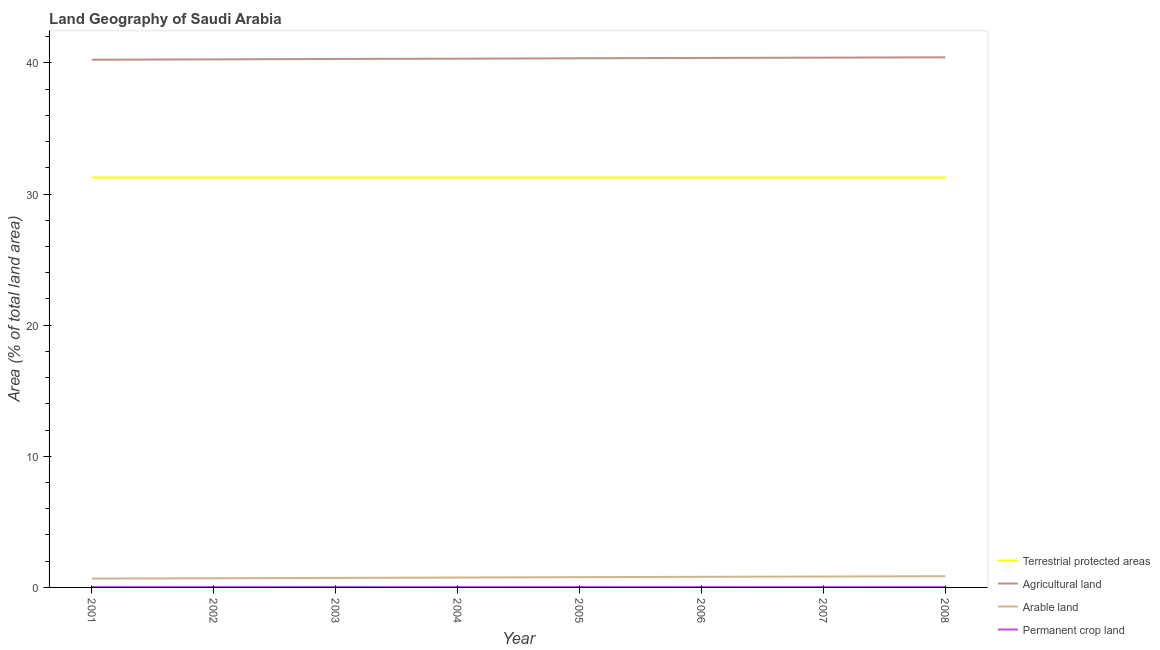How many different coloured lines are there?
Provide a short and direct response. 4. What is the percentage of area under permanent crop land in 2008?
Ensure brevity in your answer.  0.03. Across all years, what is the maximum percentage of area under permanent crop land?
Provide a succinct answer. 0.04. Across all years, what is the minimum percentage of area under permanent crop land?
Make the answer very short. 0.03. In which year was the percentage of area under permanent crop land maximum?
Ensure brevity in your answer.  2003. In which year was the percentage of area under permanent crop land minimum?
Your answer should be compact. 2004. What is the total percentage of area under permanent crop land in the graph?
Provide a short and direct response. 0.26. What is the difference between the percentage of area under permanent crop land in 2002 and that in 2003?
Your answer should be compact. -0. What is the difference between the percentage of area under arable land in 2002 and the percentage of area under agricultural land in 2004?
Your answer should be very brief. -39.63. What is the average percentage of area under permanent crop land per year?
Offer a terse response. 0.03. In the year 2003, what is the difference between the percentage of area under permanent crop land and percentage of area under arable land?
Provide a short and direct response. -0.69. In how many years, is the percentage of area under agricultural land greater than 2 %?
Make the answer very short. 8. What is the ratio of the percentage of area under arable land in 2001 to that in 2008?
Offer a terse response. 0.79. Is the percentage of area under agricultural land in 2005 less than that in 2008?
Ensure brevity in your answer.  Yes. Is the difference between the percentage of area under permanent crop land in 2003 and 2008 greater than the difference between the percentage of land under terrestrial protection in 2003 and 2008?
Your response must be concise. Yes. What is the difference between the highest and the lowest percentage of area under agricultural land?
Offer a terse response. 0.18. Is it the case that in every year, the sum of the percentage of area under permanent crop land and percentage of land under terrestrial protection is greater than the sum of percentage of area under agricultural land and percentage of area under arable land?
Provide a succinct answer. No. Does the percentage of area under arable land monotonically increase over the years?
Keep it short and to the point. Yes. Is the percentage of land under terrestrial protection strictly less than the percentage of area under arable land over the years?
Ensure brevity in your answer.  No. How many years are there in the graph?
Give a very brief answer. 8. What is the difference between two consecutive major ticks on the Y-axis?
Your answer should be very brief. 10. Does the graph contain any zero values?
Your response must be concise. No. How are the legend labels stacked?
Your response must be concise. Vertical. What is the title of the graph?
Make the answer very short. Land Geography of Saudi Arabia. What is the label or title of the Y-axis?
Your response must be concise. Area (% of total land area). What is the Area (% of total land area) in Terrestrial protected areas in 2001?
Keep it short and to the point. 31.26. What is the Area (% of total land area) of Agricultural land in 2001?
Keep it short and to the point. 40.25. What is the Area (% of total land area) of Arable land in 2001?
Your response must be concise. 0.67. What is the Area (% of total land area) of Permanent crop land in 2001?
Offer a terse response. 0.03. What is the Area (% of total land area) in Terrestrial protected areas in 2002?
Your response must be concise. 31.26. What is the Area (% of total land area) in Agricultural land in 2002?
Provide a succinct answer. 40.27. What is the Area (% of total land area) of Arable land in 2002?
Make the answer very short. 0.7. What is the Area (% of total land area) in Permanent crop land in 2002?
Offer a terse response. 0.03. What is the Area (% of total land area) in Terrestrial protected areas in 2003?
Your answer should be compact. 31.26. What is the Area (% of total land area) in Agricultural land in 2003?
Offer a terse response. 40.3. What is the Area (% of total land area) in Arable land in 2003?
Provide a short and direct response. 0.73. What is the Area (% of total land area) in Permanent crop land in 2003?
Make the answer very short. 0.04. What is the Area (% of total land area) in Terrestrial protected areas in 2004?
Give a very brief answer. 31.26. What is the Area (% of total land area) of Agricultural land in 2004?
Provide a short and direct response. 40.32. What is the Area (% of total land area) of Arable land in 2004?
Keep it short and to the point. 0.75. What is the Area (% of total land area) of Permanent crop land in 2004?
Offer a terse response. 0.03. What is the Area (% of total land area) of Terrestrial protected areas in 2005?
Offer a very short reply. 31.26. What is the Area (% of total land area) of Agricultural land in 2005?
Keep it short and to the point. 40.35. What is the Area (% of total land area) of Arable land in 2005?
Your answer should be very brief. 0.78. What is the Area (% of total land area) in Permanent crop land in 2005?
Your response must be concise. 0.03. What is the Area (% of total land area) of Terrestrial protected areas in 2006?
Provide a succinct answer. 31.26. What is the Area (% of total land area) in Agricultural land in 2006?
Your response must be concise. 40.38. What is the Area (% of total land area) in Arable land in 2006?
Provide a short and direct response. 0.81. What is the Area (% of total land area) of Permanent crop land in 2006?
Ensure brevity in your answer.  0.03. What is the Area (% of total land area) of Terrestrial protected areas in 2007?
Provide a short and direct response. 31.26. What is the Area (% of total land area) in Agricultural land in 2007?
Your response must be concise. 40.4. What is the Area (% of total land area) in Arable land in 2007?
Ensure brevity in your answer.  0.83. What is the Area (% of total land area) in Permanent crop land in 2007?
Give a very brief answer. 0.03. What is the Area (% of total land area) in Terrestrial protected areas in 2008?
Your answer should be compact. 31.26. What is the Area (% of total land area) in Agricultural land in 2008?
Ensure brevity in your answer.  40.43. What is the Area (% of total land area) of Arable land in 2008?
Make the answer very short. 0.86. What is the Area (% of total land area) in Permanent crop land in 2008?
Offer a very short reply. 0.03. Across all years, what is the maximum Area (% of total land area) in Terrestrial protected areas?
Make the answer very short. 31.26. Across all years, what is the maximum Area (% of total land area) in Agricultural land?
Keep it short and to the point. 40.43. Across all years, what is the maximum Area (% of total land area) in Arable land?
Provide a succinct answer. 0.86. Across all years, what is the maximum Area (% of total land area) of Permanent crop land?
Offer a terse response. 0.04. Across all years, what is the minimum Area (% of total land area) in Terrestrial protected areas?
Give a very brief answer. 31.26. Across all years, what is the minimum Area (% of total land area) of Agricultural land?
Make the answer very short. 40.25. Across all years, what is the minimum Area (% of total land area) in Arable land?
Your answer should be very brief. 0.67. Across all years, what is the minimum Area (% of total land area) of Permanent crop land?
Your answer should be compact. 0.03. What is the total Area (% of total land area) in Terrestrial protected areas in the graph?
Your answer should be very brief. 250.1. What is the total Area (% of total land area) in Agricultural land in the graph?
Offer a very short reply. 322.71. What is the total Area (% of total land area) in Arable land in the graph?
Offer a terse response. 6.13. What is the total Area (% of total land area) in Permanent crop land in the graph?
Your answer should be very brief. 0.26. What is the difference between the Area (% of total land area) of Terrestrial protected areas in 2001 and that in 2002?
Give a very brief answer. 0. What is the difference between the Area (% of total land area) in Agricultural land in 2001 and that in 2002?
Ensure brevity in your answer.  -0.02. What is the difference between the Area (% of total land area) of Arable land in 2001 and that in 2002?
Your answer should be very brief. -0.02. What is the difference between the Area (% of total land area) in Permanent crop land in 2001 and that in 2002?
Ensure brevity in your answer.  -0. What is the difference between the Area (% of total land area) of Terrestrial protected areas in 2001 and that in 2003?
Give a very brief answer. 0. What is the difference between the Area (% of total land area) in Agricultural land in 2001 and that in 2003?
Provide a succinct answer. -0.06. What is the difference between the Area (% of total land area) in Arable land in 2001 and that in 2003?
Ensure brevity in your answer.  -0.05. What is the difference between the Area (% of total land area) in Permanent crop land in 2001 and that in 2003?
Provide a succinct answer. -0.01. What is the difference between the Area (% of total land area) in Agricultural land in 2001 and that in 2004?
Keep it short and to the point. -0.08. What is the difference between the Area (% of total land area) in Arable land in 2001 and that in 2004?
Provide a succinct answer. -0.08. What is the difference between the Area (% of total land area) of Permanent crop land in 2001 and that in 2004?
Provide a succinct answer. 0. What is the difference between the Area (% of total land area) in Agricultural land in 2001 and that in 2005?
Your response must be concise. -0.11. What is the difference between the Area (% of total land area) in Arable land in 2001 and that in 2005?
Give a very brief answer. -0.11. What is the difference between the Area (% of total land area) of Permanent crop land in 2001 and that in 2005?
Give a very brief answer. -0. What is the difference between the Area (% of total land area) of Agricultural land in 2001 and that in 2006?
Your answer should be very brief. -0.13. What is the difference between the Area (% of total land area) of Arable land in 2001 and that in 2006?
Keep it short and to the point. -0.13. What is the difference between the Area (% of total land area) of Permanent crop land in 2001 and that in 2006?
Offer a very short reply. 0. What is the difference between the Area (% of total land area) of Terrestrial protected areas in 2001 and that in 2007?
Your answer should be very brief. 0. What is the difference between the Area (% of total land area) in Agricultural land in 2001 and that in 2007?
Give a very brief answer. -0.16. What is the difference between the Area (% of total land area) of Arable land in 2001 and that in 2007?
Your answer should be compact. -0.16. What is the difference between the Area (% of total land area) of Permanent crop land in 2001 and that in 2007?
Offer a terse response. 0. What is the difference between the Area (% of total land area) of Agricultural land in 2001 and that in 2008?
Make the answer very short. -0.18. What is the difference between the Area (% of total land area) of Arable land in 2001 and that in 2008?
Provide a short and direct response. -0.18. What is the difference between the Area (% of total land area) of Permanent crop land in 2001 and that in 2008?
Keep it short and to the point. -0. What is the difference between the Area (% of total land area) of Agricultural land in 2002 and that in 2003?
Keep it short and to the point. -0.03. What is the difference between the Area (% of total land area) in Arable land in 2002 and that in 2003?
Provide a succinct answer. -0.03. What is the difference between the Area (% of total land area) in Permanent crop land in 2002 and that in 2003?
Offer a very short reply. -0. What is the difference between the Area (% of total land area) in Terrestrial protected areas in 2002 and that in 2004?
Give a very brief answer. 0. What is the difference between the Area (% of total land area) in Agricultural land in 2002 and that in 2004?
Your response must be concise. -0.05. What is the difference between the Area (% of total land area) in Arable land in 2002 and that in 2004?
Your response must be concise. -0.06. What is the difference between the Area (% of total land area) of Permanent crop land in 2002 and that in 2004?
Ensure brevity in your answer.  0. What is the difference between the Area (% of total land area) in Agricultural land in 2002 and that in 2005?
Offer a terse response. -0.08. What is the difference between the Area (% of total land area) of Arable land in 2002 and that in 2005?
Make the answer very short. -0.08. What is the difference between the Area (% of total land area) of Permanent crop land in 2002 and that in 2005?
Provide a short and direct response. 0. What is the difference between the Area (% of total land area) in Terrestrial protected areas in 2002 and that in 2006?
Ensure brevity in your answer.  0. What is the difference between the Area (% of total land area) of Agricultural land in 2002 and that in 2006?
Provide a short and direct response. -0.11. What is the difference between the Area (% of total land area) of Arable land in 2002 and that in 2006?
Provide a succinct answer. -0.11. What is the difference between the Area (% of total land area) of Permanent crop land in 2002 and that in 2006?
Provide a short and direct response. 0. What is the difference between the Area (% of total land area) of Agricultural land in 2002 and that in 2007?
Ensure brevity in your answer.  -0.13. What is the difference between the Area (% of total land area) in Arable land in 2002 and that in 2007?
Your answer should be very brief. -0.13. What is the difference between the Area (% of total land area) in Permanent crop land in 2002 and that in 2007?
Your response must be concise. 0. What is the difference between the Area (% of total land area) of Agricultural land in 2002 and that in 2008?
Offer a terse response. -0.16. What is the difference between the Area (% of total land area) of Arable land in 2002 and that in 2008?
Provide a succinct answer. -0.16. What is the difference between the Area (% of total land area) in Agricultural land in 2003 and that in 2004?
Give a very brief answer. -0.02. What is the difference between the Area (% of total land area) of Arable land in 2003 and that in 2004?
Your response must be concise. -0.03. What is the difference between the Area (% of total land area) of Permanent crop land in 2003 and that in 2004?
Give a very brief answer. 0.01. What is the difference between the Area (% of total land area) in Agricultural land in 2003 and that in 2005?
Provide a succinct answer. -0.05. What is the difference between the Area (% of total land area) of Arable land in 2003 and that in 2005?
Your answer should be very brief. -0.06. What is the difference between the Area (% of total land area) in Permanent crop land in 2003 and that in 2005?
Make the answer very short. 0. What is the difference between the Area (% of total land area) of Terrestrial protected areas in 2003 and that in 2006?
Keep it short and to the point. 0. What is the difference between the Area (% of total land area) of Agricultural land in 2003 and that in 2006?
Provide a succinct answer. -0.08. What is the difference between the Area (% of total land area) of Arable land in 2003 and that in 2006?
Keep it short and to the point. -0.08. What is the difference between the Area (% of total land area) of Permanent crop land in 2003 and that in 2006?
Provide a short and direct response. 0.01. What is the difference between the Area (% of total land area) in Terrestrial protected areas in 2003 and that in 2007?
Your answer should be very brief. 0. What is the difference between the Area (% of total land area) in Agricultural land in 2003 and that in 2007?
Make the answer very short. -0.1. What is the difference between the Area (% of total land area) in Arable land in 2003 and that in 2007?
Give a very brief answer. -0.11. What is the difference between the Area (% of total land area) of Permanent crop land in 2003 and that in 2007?
Provide a succinct answer. 0.01. What is the difference between the Area (% of total land area) in Terrestrial protected areas in 2003 and that in 2008?
Make the answer very short. 0. What is the difference between the Area (% of total land area) of Agricultural land in 2003 and that in 2008?
Offer a very short reply. -0.13. What is the difference between the Area (% of total land area) of Arable land in 2003 and that in 2008?
Ensure brevity in your answer.  -0.13. What is the difference between the Area (% of total land area) of Permanent crop land in 2003 and that in 2008?
Your answer should be compact. 0.01. What is the difference between the Area (% of total land area) in Agricultural land in 2004 and that in 2005?
Your response must be concise. -0.03. What is the difference between the Area (% of total land area) of Arable land in 2004 and that in 2005?
Offer a terse response. -0.03. What is the difference between the Area (% of total land area) in Permanent crop land in 2004 and that in 2005?
Give a very brief answer. -0. What is the difference between the Area (% of total land area) in Agricultural land in 2004 and that in 2006?
Ensure brevity in your answer.  -0.06. What is the difference between the Area (% of total land area) of Arable land in 2004 and that in 2006?
Provide a short and direct response. -0.06. What is the difference between the Area (% of total land area) of Terrestrial protected areas in 2004 and that in 2007?
Your answer should be very brief. 0. What is the difference between the Area (% of total land area) of Agricultural land in 2004 and that in 2007?
Offer a terse response. -0.08. What is the difference between the Area (% of total land area) of Arable land in 2004 and that in 2007?
Give a very brief answer. -0.08. What is the difference between the Area (% of total land area) in Permanent crop land in 2004 and that in 2007?
Offer a very short reply. -0. What is the difference between the Area (% of total land area) of Agricultural land in 2004 and that in 2008?
Provide a short and direct response. -0.1. What is the difference between the Area (% of total land area) in Arable land in 2004 and that in 2008?
Your response must be concise. -0.1. What is the difference between the Area (% of total land area) in Permanent crop land in 2004 and that in 2008?
Your answer should be compact. -0. What is the difference between the Area (% of total land area) in Agricultural land in 2005 and that in 2006?
Give a very brief answer. -0.03. What is the difference between the Area (% of total land area) in Arable land in 2005 and that in 2006?
Offer a very short reply. -0.03. What is the difference between the Area (% of total land area) of Permanent crop land in 2005 and that in 2006?
Your response must be concise. 0. What is the difference between the Area (% of total land area) in Terrestrial protected areas in 2005 and that in 2007?
Your answer should be very brief. 0. What is the difference between the Area (% of total land area) in Agricultural land in 2005 and that in 2007?
Provide a succinct answer. -0.05. What is the difference between the Area (% of total land area) of Arable land in 2005 and that in 2007?
Offer a terse response. -0.05. What is the difference between the Area (% of total land area) in Permanent crop land in 2005 and that in 2007?
Offer a very short reply. 0. What is the difference between the Area (% of total land area) of Terrestrial protected areas in 2005 and that in 2008?
Give a very brief answer. 0. What is the difference between the Area (% of total land area) of Agricultural land in 2005 and that in 2008?
Your response must be concise. -0.07. What is the difference between the Area (% of total land area) in Arable land in 2005 and that in 2008?
Keep it short and to the point. -0.07. What is the difference between the Area (% of total land area) in Terrestrial protected areas in 2006 and that in 2007?
Ensure brevity in your answer.  0. What is the difference between the Area (% of total land area) of Agricultural land in 2006 and that in 2007?
Give a very brief answer. -0.02. What is the difference between the Area (% of total land area) in Arable land in 2006 and that in 2007?
Provide a short and direct response. -0.02. What is the difference between the Area (% of total land area) of Permanent crop land in 2006 and that in 2007?
Make the answer very short. -0. What is the difference between the Area (% of total land area) of Agricultural land in 2006 and that in 2008?
Give a very brief answer. -0.05. What is the difference between the Area (% of total land area) in Arable land in 2006 and that in 2008?
Your answer should be compact. -0.05. What is the difference between the Area (% of total land area) in Permanent crop land in 2006 and that in 2008?
Your answer should be compact. -0. What is the difference between the Area (% of total land area) in Agricultural land in 2007 and that in 2008?
Ensure brevity in your answer.  -0.02. What is the difference between the Area (% of total land area) in Arable land in 2007 and that in 2008?
Offer a very short reply. -0.02. What is the difference between the Area (% of total land area) in Permanent crop land in 2007 and that in 2008?
Your answer should be very brief. -0. What is the difference between the Area (% of total land area) of Terrestrial protected areas in 2001 and the Area (% of total land area) of Agricultural land in 2002?
Provide a short and direct response. -9.01. What is the difference between the Area (% of total land area) in Terrestrial protected areas in 2001 and the Area (% of total land area) in Arable land in 2002?
Provide a succinct answer. 30.56. What is the difference between the Area (% of total land area) of Terrestrial protected areas in 2001 and the Area (% of total land area) of Permanent crop land in 2002?
Give a very brief answer. 31.23. What is the difference between the Area (% of total land area) in Agricultural land in 2001 and the Area (% of total land area) in Arable land in 2002?
Ensure brevity in your answer.  39.55. What is the difference between the Area (% of total land area) of Agricultural land in 2001 and the Area (% of total land area) of Permanent crop land in 2002?
Provide a succinct answer. 40.21. What is the difference between the Area (% of total land area) of Arable land in 2001 and the Area (% of total land area) of Permanent crop land in 2002?
Make the answer very short. 0.64. What is the difference between the Area (% of total land area) of Terrestrial protected areas in 2001 and the Area (% of total land area) of Agricultural land in 2003?
Offer a terse response. -9.04. What is the difference between the Area (% of total land area) in Terrestrial protected areas in 2001 and the Area (% of total land area) in Arable land in 2003?
Offer a terse response. 30.54. What is the difference between the Area (% of total land area) in Terrestrial protected areas in 2001 and the Area (% of total land area) in Permanent crop land in 2003?
Your response must be concise. 31.22. What is the difference between the Area (% of total land area) in Agricultural land in 2001 and the Area (% of total land area) in Arable land in 2003?
Offer a terse response. 39.52. What is the difference between the Area (% of total land area) in Agricultural land in 2001 and the Area (% of total land area) in Permanent crop land in 2003?
Offer a terse response. 40.21. What is the difference between the Area (% of total land area) of Arable land in 2001 and the Area (% of total land area) of Permanent crop land in 2003?
Ensure brevity in your answer.  0.64. What is the difference between the Area (% of total land area) in Terrestrial protected areas in 2001 and the Area (% of total land area) in Agricultural land in 2004?
Ensure brevity in your answer.  -9.06. What is the difference between the Area (% of total land area) of Terrestrial protected areas in 2001 and the Area (% of total land area) of Arable land in 2004?
Offer a terse response. 30.51. What is the difference between the Area (% of total land area) in Terrestrial protected areas in 2001 and the Area (% of total land area) in Permanent crop land in 2004?
Your answer should be very brief. 31.23. What is the difference between the Area (% of total land area) in Agricultural land in 2001 and the Area (% of total land area) in Arable land in 2004?
Offer a very short reply. 39.49. What is the difference between the Area (% of total land area) of Agricultural land in 2001 and the Area (% of total land area) of Permanent crop land in 2004?
Provide a short and direct response. 40.22. What is the difference between the Area (% of total land area) of Arable land in 2001 and the Area (% of total land area) of Permanent crop land in 2004?
Give a very brief answer. 0.64. What is the difference between the Area (% of total land area) of Terrestrial protected areas in 2001 and the Area (% of total land area) of Agricultural land in 2005?
Offer a very short reply. -9.09. What is the difference between the Area (% of total land area) of Terrestrial protected areas in 2001 and the Area (% of total land area) of Arable land in 2005?
Your response must be concise. 30.48. What is the difference between the Area (% of total land area) of Terrestrial protected areas in 2001 and the Area (% of total land area) of Permanent crop land in 2005?
Your response must be concise. 31.23. What is the difference between the Area (% of total land area) in Agricultural land in 2001 and the Area (% of total land area) in Arable land in 2005?
Ensure brevity in your answer.  39.46. What is the difference between the Area (% of total land area) of Agricultural land in 2001 and the Area (% of total land area) of Permanent crop land in 2005?
Your response must be concise. 40.21. What is the difference between the Area (% of total land area) of Arable land in 2001 and the Area (% of total land area) of Permanent crop land in 2005?
Ensure brevity in your answer.  0.64. What is the difference between the Area (% of total land area) in Terrestrial protected areas in 2001 and the Area (% of total land area) in Agricultural land in 2006?
Give a very brief answer. -9.12. What is the difference between the Area (% of total land area) in Terrestrial protected areas in 2001 and the Area (% of total land area) in Arable land in 2006?
Your response must be concise. 30.45. What is the difference between the Area (% of total land area) in Terrestrial protected areas in 2001 and the Area (% of total land area) in Permanent crop land in 2006?
Make the answer very short. 31.23. What is the difference between the Area (% of total land area) in Agricultural land in 2001 and the Area (% of total land area) in Arable land in 2006?
Offer a very short reply. 39.44. What is the difference between the Area (% of total land area) in Agricultural land in 2001 and the Area (% of total land area) in Permanent crop land in 2006?
Offer a very short reply. 40.22. What is the difference between the Area (% of total land area) of Arable land in 2001 and the Area (% of total land area) of Permanent crop land in 2006?
Make the answer very short. 0.64. What is the difference between the Area (% of total land area) in Terrestrial protected areas in 2001 and the Area (% of total land area) in Agricultural land in 2007?
Your response must be concise. -9.14. What is the difference between the Area (% of total land area) in Terrestrial protected areas in 2001 and the Area (% of total land area) in Arable land in 2007?
Your answer should be very brief. 30.43. What is the difference between the Area (% of total land area) of Terrestrial protected areas in 2001 and the Area (% of total land area) of Permanent crop land in 2007?
Provide a short and direct response. 31.23. What is the difference between the Area (% of total land area) in Agricultural land in 2001 and the Area (% of total land area) in Arable land in 2007?
Your answer should be very brief. 39.41. What is the difference between the Area (% of total land area) of Agricultural land in 2001 and the Area (% of total land area) of Permanent crop land in 2007?
Your answer should be very brief. 40.22. What is the difference between the Area (% of total land area) in Arable land in 2001 and the Area (% of total land area) in Permanent crop land in 2007?
Offer a very short reply. 0.64. What is the difference between the Area (% of total land area) of Terrestrial protected areas in 2001 and the Area (% of total land area) of Agricultural land in 2008?
Offer a very short reply. -9.17. What is the difference between the Area (% of total land area) in Terrestrial protected areas in 2001 and the Area (% of total land area) in Arable land in 2008?
Your response must be concise. 30.41. What is the difference between the Area (% of total land area) in Terrestrial protected areas in 2001 and the Area (% of total land area) in Permanent crop land in 2008?
Provide a short and direct response. 31.23. What is the difference between the Area (% of total land area) in Agricultural land in 2001 and the Area (% of total land area) in Arable land in 2008?
Make the answer very short. 39.39. What is the difference between the Area (% of total land area) in Agricultural land in 2001 and the Area (% of total land area) in Permanent crop land in 2008?
Ensure brevity in your answer.  40.21. What is the difference between the Area (% of total land area) in Arable land in 2001 and the Area (% of total land area) in Permanent crop land in 2008?
Provide a short and direct response. 0.64. What is the difference between the Area (% of total land area) of Terrestrial protected areas in 2002 and the Area (% of total land area) of Agricultural land in 2003?
Give a very brief answer. -9.04. What is the difference between the Area (% of total land area) in Terrestrial protected areas in 2002 and the Area (% of total land area) in Arable land in 2003?
Your response must be concise. 30.54. What is the difference between the Area (% of total land area) of Terrestrial protected areas in 2002 and the Area (% of total land area) of Permanent crop land in 2003?
Give a very brief answer. 31.22. What is the difference between the Area (% of total land area) of Agricultural land in 2002 and the Area (% of total land area) of Arable land in 2003?
Offer a very short reply. 39.55. What is the difference between the Area (% of total land area) of Agricultural land in 2002 and the Area (% of total land area) of Permanent crop land in 2003?
Make the answer very short. 40.23. What is the difference between the Area (% of total land area) in Arable land in 2002 and the Area (% of total land area) in Permanent crop land in 2003?
Offer a very short reply. 0.66. What is the difference between the Area (% of total land area) in Terrestrial protected areas in 2002 and the Area (% of total land area) in Agricultural land in 2004?
Your response must be concise. -9.06. What is the difference between the Area (% of total land area) in Terrestrial protected areas in 2002 and the Area (% of total land area) in Arable land in 2004?
Provide a short and direct response. 30.51. What is the difference between the Area (% of total land area) of Terrestrial protected areas in 2002 and the Area (% of total land area) of Permanent crop land in 2004?
Ensure brevity in your answer.  31.23. What is the difference between the Area (% of total land area) of Agricultural land in 2002 and the Area (% of total land area) of Arable land in 2004?
Make the answer very short. 39.52. What is the difference between the Area (% of total land area) in Agricultural land in 2002 and the Area (% of total land area) in Permanent crop land in 2004?
Your answer should be very brief. 40.24. What is the difference between the Area (% of total land area) of Arable land in 2002 and the Area (% of total land area) of Permanent crop land in 2004?
Provide a short and direct response. 0.67. What is the difference between the Area (% of total land area) of Terrestrial protected areas in 2002 and the Area (% of total land area) of Agricultural land in 2005?
Make the answer very short. -9.09. What is the difference between the Area (% of total land area) of Terrestrial protected areas in 2002 and the Area (% of total land area) of Arable land in 2005?
Give a very brief answer. 30.48. What is the difference between the Area (% of total land area) of Terrestrial protected areas in 2002 and the Area (% of total land area) of Permanent crop land in 2005?
Offer a very short reply. 31.23. What is the difference between the Area (% of total land area) of Agricultural land in 2002 and the Area (% of total land area) of Arable land in 2005?
Offer a terse response. 39.49. What is the difference between the Area (% of total land area) in Agricultural land in 2002 and the Area (% of total land area) in Permanent crop land in 2005?
Your response must be concise. 40.24. What is the difference between the Area (% of total land area) of Arable land in 2002 and the Area (% of total land area) of Permanent crop land in 2005?
Ensure brevity in your answer.  0.67. What is the difference between the Area (% of total land area) of Terrestrial protected areas in 2002 and the Area (% of total land area) of Agricultural land in 2006?
Offer a terse response. -9.12. What is the difference between the Area (% of total land area) of Terrestrial protected areas in 2002 and the Area (% of total land area) of Arable land in 2006?
Your answer should be compact. 30.45. What is the difference between the Area (% of total land area) of Terrestrial protected areas in 2002 and the Area (% of total land area) of Permanent crop land in 2006?
Make the answer very short. 31.23. What is the difference between the Area (% of total land area) of Agricultural land in 2002 and the Area (% of total land area) of Arable land in 2006?
Provide a short and direct response. 39.46. What is the difference between the Area (% of total land area) of Agricultural land in 2002 and the Area (% of total land area) of Permanent crop land in 2006?
Provide a short and direct response. 40.24. What is the difference between the Area (% of total land area) in Arable land in 2002 and the Area (% of total land area) in Permanent crop land in 2006?
Make the answer very short. 0.67. What is the difference between the Area (% of total land area) in Terrestrial protected areas in 2002 and the Area (% of total land area) in Agricultural land in 2007?
Your answer should be very brief. -9.14. What is the difference between the Area (% of total land area) in Terrestrial protected areas in 2002 and the Area (% of total land area) in Arable land in 2007?
Offer a very short reply. 30.43. What is the difference between the Area (% of total land area) in Terrestrial protected areas in 2002 and the Area (% of total land area) in Permanent crop land in 2007?
Ensure brevity in your answer.  31.23. What is the difference between the Area (% of total land area) in Agricultural land in 2002 and the Area (% of total land area) in Arable land in 2007?
Offer a terse response. 39.44. What is the difference between the Area (% of total land area) in Agricultural land in 2002 and the Area (% of total land area) in Permanent crop land in 2007?
Your response must be concise. 40.24. What is the difference between the Area (% of total land area) of Arable land in 2002 and the Area (% of total land area) of Permanent crop land in 2007?
Offer a very short reply. 0.67. What is the difference between the Area (% of total land area) in Terrestrial protected areas in 2002 and the Area (% of total land area) in Agricultural land in 2008?
Your response must be concise. -9.17. What is the difference between the Area (% of total land area) of Terrestrial protected areas in 2002 and the Area (% of total land area) of Arable land in 2008?
Your answer should be compact. 30.41. What is the difference between the Area (% of total land area) of Terrestrial protected areas in 2002 and the Area (% of total land area) of Permanent crop land in 2008?
Ensure brevity in your answer.  31.23. What is the difference between the Area (% of total land area) of Agricultural land in 2002 and the Area (% of total land area) of Arable land in 2008?
Provide a succinct answer. 39.41. What is the difference between the Area (% of total land area) in Agricultural land in 2002 and the Area (% of total land area) in Permanent crop land in 2008?
Ensure brevity in your answer.  40.24. What is the difference between the Area (% of total land area) in Arable land in 2002 and the Area (% of total land area) in Permanent crop land in 2008?
Your response must be concise. 0.67. What is the difference between the Area (% of total land area) of Terrestrial protected areas in 2003 and the Area (% of total land area) of Agricultural land in 2004?
Offer a very short reply. -9.06. What is the difference between the Area (% of total land area) in Terrestrial protected areas in 2003 and the Area (% of total land area) in Arable land in 2004?
Make the answer very short. 30.51. What is the difference between the Area (% of total land area) of Terrestrial protected areas in 2003 and the Area (% of total land area) of Permanent crop land in 2004?
Ensure brevity in your answer.  31.23. What is the difference between the Area (% of total land area) in Agricultural land in 2003 and the Area (% of total land area) in Arable land in 2004?
Your response must be concise. 39.55. What is the difference between the Area (% of total land area) of Agricultural land in 2003 and the Area (% of total land area) of Permanent crop land in 2004?
Give a very brief answer. 40.27. What is the difference between the Area (% of total land area) in Arable land in 2003 and the Area (% of total land area) in Permanent crop land in 2004?
Provide a succinct answer. 0.7. What is the difference between the Area (% of total land area) of Terrestrial protected areas in 2003 and the Area (% of total land area) of Agricultural land in 2005?
Offer a terse response. -9.09. What is the difference between the Area (% of total land area) of Terrestrial protected areas in 2003 and the Area (% of total land area) of Arable land in 2005?
Your answer should be compact. 30.48. What is the difference between the Area (% of total land area) in Terrestrial protected areas in 2003 and the Area (% of total land area) in Permanent crop land in 2005?
Ensure brevity in your answer.  31.23. What is the difference between the Area (% of total land area) of Agricultural land in 2003 and the Area (% of total land area) of Arable land in 2005?
Keep it short and to the point. 39.52. What is the difference between the Area (% of total land area) of Agricultural land in 2003 and the Area (% of total land area) of Permanent crop land in 2005?
Your answer should be compact. 40.27. What is the difference between the Area (% of total land area) of Arable land in 2003 and the Area (% of total land area) of Permanent crop land in 2005?
Offer a very short reply. 0.69. What is the difference between the Area (% of total land area) of Terrestrial protected areas in 2003 and the Area (% of total land area) of Agricultural land in 2006?
Offer a terse response. -9.12. What is the difference between the Area (% of total land area) in Terrestrial protected areas in 2003 and the Area (% of total land area) in Arable land in 2006?
Offer a terse response. 30.45. What is the difference between the Area (% of total land area) in Terrestrial protected areas in 2003 and the Area (% of total land area) in Permanent crop land in 2006?
Offer a very short reply. 31.23. What is the difference between the Area (% of total land area) in Agricultural land in 2003 and the Area (% of total land area) in Arable land in 2006?
Provide a short and direct response. 39.49. What is the difference between the Area (% of total land area) in Agricultural land in 2003 and the Area (% of total land area) in Permanent crop land in 2006?
Provide a succinct answer. 40.27. What is the difference between the Area (% of total land area) in Arable land in 2003 and the Area (% of total land area) in Permanent crop land in 2006?
Provide a short and direct response. 0.7. What is the difference between the Area (% of total land area) of Terrestrial protected areas in 2003 and the Area (% of total land area) of Agricultural land in 2007?
Your answer should be very brief. -9.14. What is the difference between the Area (% of total land area) of Terrestrial protected areas in 2003 and the Area (% of total land area) of Arable land in 2007?
Offer a terse response. 30.43. What is the difference between the Area (% of total land area) in Terrestrial protected areas in 2003 and the Area (% of total land area) in Permanent crop land in 2007?
Your answer should be very brief. 31.23. What is the difference between the Area (% of total land area) of Agricultural land in 2003 and the Area (% of total land area) of Arable land in 2007?
Make the answer very short. 39.47. What is the difference between the Area (% of total land area) in Agricultural land in 2003 and the Area (% of total land area) in Permanent crop land in 2007?
Offer a very short reply. 40.27. What is the difference between the Area (% of total land area) in Arable land in 2003 and the Area (% of total land area) in Permanent crop land in 2007?
Give a very brief answer. 0.69. What is the difference between the Area (% of total land area) of Terrestrial protected areas in 2003 and the Area (% of total land area) of Agricultural land in 2008?
Provide a succinct answer. -9.17. What is the difference between the Area (% of total land area) in Terrestrial protected areas in 2003 and the Area (% of total land area) in Arable land in 2008?
Offer a very short reply. 30.41. What is the difference between the Area (% of total land area) in Terrestrial protected areas in 2003 and the Area (% of total land area) in Permanent crop land in 2008?
Give a very brief answer. 31.23. What is the difference between the Area (% of total land area) of Agricultural land in 2003 and the Area (% of total land area) of Arable land in 2008?
Ensure brevity in your answer.  39.45. What is the difference between the Area (% of total land area) in Agricultural land in 2003 and the Area (% of total land area) in Permanent crop land in 2008?
Provide a succinct answer. 40.27. What is the difference between the Area (% of total land area) in Arable land in 2003 and the Area (% of total land area) in Permanent crop land in 2008?
Make the answer very short. 0.69. What is the difference between the Area (% of total land area) in Terrestrial protected areas in 2004 and the Area (% of total land area) in Agricultural land in 2005?
Offer a terse response. -9.09. What is the difference between the Area (% of total land area) of Terrestrial protected areas in 2004 and the Area (% of total land area) of Arable land in 2005?
Ensure brevity in your answer.  30.48. What is the difference between the Area (% of total land area) in Terrestrial protected areas in 2004 and the Area (% of total land area) in Permanent crop land in 2005?
Make the answer very short. 31.23. What is the difference between the Area (% of total land area) of Agricultural land in 2004 and the Area (% of total land area) of Arable land in 2005?
Provide a short and direct response. 39.54. What is the difference between the Area (% of total land area) in Agricultural land in 2004 and the Area (% of total land area) in Permanent crop land in 2005?
Provide a succinct answer. 40.29. What is the difference between the Area (% of total land area) of Arable land in 2004 and the Area (% of total land area) of Permanent crop land in 2005?
Provide a succinct answer. 0.72. What is the difference between the Area (% of total land area) of Terrestrial protected areas in 2004 and the Area (% of total land area) of Agricultural land in 2006?
Ensure brevity in your answer.  -9.12. What is the difference between the Area (% of total land area) in Terrestrial protected areas in 2004 and the Area (% of total land area) in Arable land in 2006?
Your response must be concise. 30.45. What is the difference between the Area (% of total land area) of Terrestrial protected areas in 2004 and the Area (% of total land area) of Permanent crop land in 2006?
Make the answer very short. 31.23. What is the difference between the Area (% of total land area) of Agricultural land in 2004 and the Area (% of total land area) of Arable land in 2006?
Your answer should be very brief. 39.51. What is the difference between the Area (% of total land area) of Agricultural land in 2004 and the Area (% of total land area) of Permanent crop land in 2006?
Your response must be concise. 40.29. What is the difference between the Area (% of total land area) in Arable land in 2004 and the Area (% of total land area) in Permanent crop land in 2006?
Provide a short and direct response. 0.72. What is the difference between the Area (% of total land area) of Terrestrial protected areas in 2004 and the Area (% of total land area) of Agricultural land in 2007?
Provide a succinct answer. -9.14. What is the difference between the Area (% of total land area) in Terrestrial protected areas in 2004 and the Area (% of total land area) in Arable land in 2007?
Make the answer very short. 30.43. What is the difference between the Area (% of total land area) of Terrestrial protected areas in 2004 and the Area (% of total land area) of Permanent crop land in 2007?
Your answer should be compact. 31.23. What is the difference between the Area (% of total land area) of Agricultural land in 2004 and the Area (% of total land area) of Arable land in 2007?
Ensure brevity in your answer.  39.49. What is the difference between the Area (% of total land area) in Agricultural land in 2004 and the Area (% of total land area) in Permanent crop land in 2007?
Keep it short and to the point. 40.29. What is the difference between the Area (% of total land area) of Arable land in 2004 and the Area (% of total land area) of Permanent crop land in 2007?
Your answer should be compact. 0.72. What is the difference between the Area (% of total land area) in Terrestrial protected areas in 2004 and the Area (% of total land area) in Agricultural land in 2008?
Offer a very short reply. -9.17. What is the difference between the Area (% of total land area) of Terrestrial protected areas in 2004 and the Area (% of total land area) of Arable land in 2008?
Your response must be concise. 30.41. What is the difference between the Area (% of total land area) in Terrestrial protected areas in 2004 and the Area (% of total land area) in Permanent crop land in 2008?
Provide a short and direct response. 31.23. What is the difference between the Area (% of total land area) in Agricultural land in 2004 and the Area (% of total land area) in Arable land in 2008?
Give a very brief answer. 39.47. What is the difference between the Area (% of total land area) in Agricultural land in 2004 and the Area (% of total land area) in Permanent crop land in 2008?
Offer a terse response. 40.29. What is the difference between the Area (% of total land area) of Arable land in 2004 and the Area (% of total land area) of Permanent crop land in 2008?
Keep it short and to the point. 0.72. What is the difference between the Area (% of total land area) in Terrestrial protected areas in 2005 and the Area (% of total land area) in Agricultural land in 2006?
Your answer should be very brief. -9.12. What is the difference between the Area (% of total land area) of Terrestrial protected areas in 2005 and the Area (% of total land area) of Arable land in 2006?
Offer a very short reply. 30.45. What is the difference between the Area (% of total land area) of Terrestrial protected areas in 2005 and the Area (% of total land area) of Permanent crop land in 2006?
Your answer should be compact. 31.23. What is the difference between the Area (% of total land area) of Agricultural land in 2005 and the Area (% of total land area) of Arable land in 2006?
Provide a succinct answer. 39.55. What is the difference between the Area (% of total land area) of Agricultural land in 2005 and the Area (% of total land area) of Permanent crop land in 2006?
Offer a very short reply. 40.32. What is the difference between the Area (% of total land area) in Arable land in 2005 and the Area (% of total land area) in Permanent crop land in 2006?
Provide a short and direct response. 0.75. What is the difference between the Area (% of total land area) of Terrestrial protected areas in 2005 and the Area (% of total land area) of Agricultural land in 2007?
Your answer should be very brief. -9.14. What is the difference between the Area (% of total land area) of Terrestrial protected areas in 2005 and the Area (% of total land area) of Arable land in 2007?
Offer a terse response. 30.43. What is the difference between the Area (% of total land area) in Terrestrial protected areas in 2005 and the Area (% of total land area) in Permanent crop land in 2007?
Your answer should be very brief. 31.23. What is the difference between the Area (% of total land area) of Agricultural land in 2005 and the Area (% of total land area) of Arable land in 2007?
Make the answer very short. 39.52. What is the difference between the Area (% of total land area) in Agricultural land in 2005 and the Area (% of total land area) in Permanent crop land in 2007?
Your answer should be very brief. 40.32. What is the difference between the Area (% of total land area) in Arable land in 2005 and the Area (% of total land area) in Permanent crop land in 2007?
Offer a terse response. 0.75. What is the difference between the Area (% of total land area) in Terrestrial protected areas in 2005 and the Area (% of total land area) in Agricultural land in 2008?
Offer a terse response. -9.17. What is the difference between the Area (% of total land area) of Terrestrial protected areas in 2005 and the Area (% of total land area) of Arable land in 2008?
Offer a very short reply. 30.41. What is the difference between the Area (% of total land area) in Terrestrial protected areas in 2005 and the Area (% of total land area) in Permanent crop land in 2008?
Provide a short and direct response. 31.23. What is the difference between the Area (% of total land area) of Agricultural land in 2005 and the Area (% of total land area) of Arable land in 2008?
Your answer should be very brief. 39.5. What is the difference between the Area (% of total land area) of Agricultural land in 2005 and the Area (% of total land area) of Permanent crop land in 2008?
Give a very brief answer. 40.32. What is the difference between the Area (% of total land area) of Arable land in 2005 and the Area (% of total land area) of Permanent crop land in 2008?
Keep it short and to the point. 0.75. What is the difference between the Area (% of total land area) of Terrestrial protected areas in 2006 and the Area (% of total land area) of Agricultural land in 2007?
Keep it short and to the point. -9.14. What is the difference between the Area (% of total land area) of Terrestrial protected areas in 2006 and the Area (% of total land area) of Arable land in 2007?
Give a very brief answer. 30.43. What is the difference between the Area (% of total land area) of Terrestrial protected areas in 2006 and the Area (% of total land area) of Permanent crop land in 2007?
Provide a succinct answer. 31.23. What is the difference between the Area (% of total land area) of Agricultural land in 2006 and the Area (% of total land area) of Arable land in 2007?
Your response must be concise. 39.55. What is the difference between the Area (% of total land area) in Agricultural land in 2006 and the Area (% of total land area) in Permanent crop land in 2007?
Give a very brief answer. 40.35. What is the difference between the Area (% of total land area) in Arable land in 2006 and the Area (% of total land area) in Permanent crop land in 2007?
Your answer should be compact. 0.78. What is the difference between the Area (% of total land area) of Terrestrial protected areas in 2006 and the Area (% of total land area) of Agricultural land in 2008?
Offer a very short reply. -9.17. What is the difference between the Area (% of total land area) of Terrestrial protected areas in 2006 and the Area (% of total land area) of Arable land in 2008?
Make the answer very short. 30.41. What is the difference between the Area (% of total land area) in Terrestrial protected areas in 2006 and the Area (% of total land area) in Permanent crop land in 2008?
Offer a terse response. 31.23. What is the difference between the Area (% of total land area) in Agricultural land in 2006 and the Area (% of total land area) in Arable land in 2008?
Offer a very short reply. 39.52. What is the difference between the Area (% of total land area) of Agricultural land in 2006 and the Area (% of total land area) of Permanent crop land in 2008?
Give a very brief answer. 40.35. What is the difference between the Area (% of total land area) of Arable land in 2006 and the Area (% of total land area) of Permanent crop land in 2008?
Your answer should be very brief. 0.78. What is the difference between the Area (% of total land area) of Terrestrial protected areas in 2007 and the Area (% of total land area) of Agricultural land in 2008?
Your response must be concise. -9.17. What is the difference between the Area (% of total land area) in Terrestrial protected areas in 2007 and the Area (% of total land area) in Arable land in 2008?
Ensure brevity in your answer.  30.41. What is the difference between the Area (% of total land area) in Terrestrial protected areas in 2007 and the Area (% of total land area) in Permanent crop land in 2008?
Offer a very short reply. 31.23. What is the difference between the Area (% of total land area) of Agricultural land in 2007 and the Area (% of total land area) of Arable land in 2008?
Offer a very short reply. 39.55. What is the difference between the Area (% of total land area) of Agricultural land in 2007 and the Area (% of total land area) of Permanent crop land in 2008?
Ensure brevity in your answer.  40.37. What is the difference between the Area (% of total land area) in Arable land in 2007 and the Area (% of total land area) in Permanent crop land in 2008?
Offer a very short reply. 0.8. What is the average Area (% of total land area) in Terrestrial protected areas per year?
Provide a succinct answer. 31.26. What is the average Area (% of total land area) of Agricultural land per year?
Offer a very short reply. 40.34. What is the average Area (% of total land area) of Arable land per year?
Offer a very short reply. 0.77. What is the average Area (% of total land area) in Permanent crop land per year?
Your answer should be compact. 0.03. In the year 2001, what is the difference between the Area (% of total land area) in Terrestrial protected areas and Area (% of total land area) in Agricultural land?
Your answer should be compact. -8.98. In the year 2001, what is the difference between the Area (% of total land area) of Terrestrial protected areas and Area (% of total land area) of Arable land?
Make the answer very short. 30.59. In the year 2001, what is the difference between the Area (% of total land area) of Terrestrial protected areas and Area (% of total land area) of Permanent crop land?
Provide a short and direct response. 31.23. In the year 2001, what is the difference between the Area (% of total land area) in Agricultural land and Area (% of total land area) in Arable land?
Offer a terse response. 39.57. In the year 2001, what is the difference between the Area (% of total land area) in Agricultural land and Area (% of total land area) in Permanent crop land?
Your answer should be compact. 40.22. In the year 2001, what is the difference between the Area (% of total land area) of Arable land and Area (% of total land area) of Permanent crop land?
Ensure brevity in your answer.  0.64. In the year 2002, what is the difference between the Area (% of total land area) in Terrestrial protected areas and Area (% of total land area) in Agricultural land?
Your answer should be compact. -9.01. In the year 2002, what is the difference between the Area (% of total land area) in Terrestrial protected areas and Area (% of total land area) in Arable land?
Make the answer very short. 30.56. In the year 2002, what is the difference between the Area (% of total land area) of Terrestrial protected areas and Area (% of total land area) of Permanent crop land?
Provide a short and direct response. 31.23. In the year 2002, what is the difference between the Area (% of total land area) in Agricultural land and Area (% of total land area) in Arable land?
Keep it short and to the point. 39.57. In the year 2002, what is the difference between the Area (% of total land area) in Agricultural land and Area (% of total land area) in Permanent crop land?
Make the answer very short. 40.24. In the year 2002, what is the difference between the Area (% of total land area) of Arable land and Area (% of total land area) of Permanent crop land?
Give a very brief answer. 0.67. In the year 2003, what is the difference between the Area (% of total land area) in Terrestrial protected areas and Area (% of total land area) in Agricultural land?
Your response must be concise. -9.04. In the year 2003, what is the difference between the Area (% of total land area) in Terrestrial protected areas and Area (% of total land area) in Arable land?
Your response must be concise. 30.54. In the year 2003, what is the difference between the Area (% of total land area) of Terrestrial protected areas and Area (% of total land area) of Permanent crop land?
Offer a terse response. 31.22. In the year 2003, what is the difference between the Area (% of total land area) in Agricultural land and Area (% of total land area) in Arable land?
Make the answer very short. 39.58. In the year 2003, what is the difference between the Area (% of total land area) in Agricultural land and Area (% of total land area) in Permanent crop land?
Give a very brief answer. 40.27. In the year 2003, what is the difference between the Area (% of total land area) in Arable land and Area (% of total land area) in Permanent crop land?
Offer a terse response. 0.69. In the year 2004, what is the difference between the Area (% of total land area) of Terrestrial protected areas and Area (% of total land area) of Agricultural land?
Your answer should be compact. -9.06. In the year 2004, what is the difference between the Area (% of total land area) of Terrestrial protected areas and Area (% of total land area) of Arable land?
Keep it short and to the point. 30.51. In the year 2004, what is the difference between the Area (% of total land area) of Terrestrial protected areas and Area (% of total land area) of Permanent crop land?
Your answer should be very brief. 31.23. In the year 2004, what is the difference between the Area (% of total land area) in Agricultural land and Area (% of total land area) in Arable land?
Give a very brief answer. 39.57. In the year 2004, what is the difference between the Area (% of total land area) of Agricultural land and Area (% of total land area) of Permanent crop land?
Make the answer very short. 40.29. In the year 2004, what is the difference between the Area (% of total land area) of Arable land and Area (% of total land area) of Permanent crop land?
Ensure brevity in your answer.  0.72. In the year 2005, what is the difference between the Area (% of total land area) in Terrestrial protected areas and Area (% of total land area) in Agricultural land?
Your answer should be compact. -9.09. In the year 2005, what is the difference between the Area (% of total land area) in Terrestrial protected areas and Area (% of total land area) in Arable land?
Make the answer very short. 30.48. In the year 2005, what is the difference between the Area (% of total land area) of Terrestrial protected areas and Area (% of total land area) of Permanent crop land?
Your response must be concise. 31.23. In the year 2005, what is the difference between the Area (% of total land area) of Agricultural land and Area (% of total land area) of Arable land?
Provide a short and direct response. 39.57. In the year 2005, what is the difference between the Area (% of total land area) of Agricultural land and Area (% of total land area) of Permanent crop land?
Offer a very short reply. 40.32. In the year 2005, what is the difference between the Area (% of total land area) in Arable land and Area (% of total land area) in Permanent crop land?
Give a very brief answer. 0.75. In the year 2006, what is the difference between the Area (% of total land area) of Terrestrial protected areas and Area (% of total land area) of Agricultural land?
Offer a terse response. -9.12. In the year 2006, what is the difference between the Area (% of total land area) of Terrestrial protected areas and Area (% of total land area) of Arable land?
Provide a succinct answer. 30.45. In the year 2006, what is the difference between the Area (% of total land area) of Terrestrial protected areas and Area (% of total land area) of Permanent crop land?
Provide a succinct answer. 31.23. In the year 2006, what is the difference between the Area (% of total land area) in Agricultural land and Area (% of total land area) in Arable land?
Offer a very short reply. 39.57. In the year 2006, what is the difference between the Area (% of total land area) in Agricultural land and Area (% of total land area) in Permanent crop land?
Offer a terse response. 40.35. In the year 2006, what is the difference between the Area (% of total land area) in Arable land and Area (% of total land area) in Permanent crop land?
Give a very brief answer. 0.78. In the year 2007, what is the difference between the Area (% of total land area) of Terrestrial protected areas and Area (% of total land area) of Agricultural land?
Your response must be concise. -9.14. In the year 2007, what is the difference between the Area (% of total land area) in Terrestrial protected areas and Area (% of total land area) in Arable land?
Provide a short and direct response. 30.43. In the year 2007, what is the difference between the Area (% of total land area) of Terrestrial protected areas and Area (% of total land area) of Permanent crop land?
Your answer should be very brief. 31.23. In the year 2007, what is the difference between the Area (% of total land area) in Agricultural land and Area (% of total land area) in Arable land?
Your answer should be very brief. 39.57. In the year 2007, what is the difference between the Area (% of total land area) of Agricultural land and Area (% of total land area) of Permanent crop land?
Give a very brief answer. 40.37. In the year 2007, what is the difference between the Area (% of total land area) in Arable land and Area (% of total land area) in Permanent crop land?
Make the answer very short. 0.8. In the year 2008, what is the difference between the Area (% of total land area) of Terrestrial protected areas and Area (% of total land area) of Agricultural land?
Your answer should be very brief. -9.17. In the year 2008, what is the difference between the Area (% of total land area) in Terrestrial protected areas and Area (% of total land area) in Arable land?
Your answer should be compact. 30.41. In the year 2008, what is the difference between the Area (% of total land area) in Terrestrial protected areas and Area (% of total land area) in Permanent crop land?
Your response must be concise. 31.23. In the year 2008, what is the difference between the Area (% of total land area) of Agricultural land and Area (% of total land area) of Arable land?
Offer a very short reply. 39.57. In the year 2008, what is the difference between the Area (% of total land area) of Agricultural land and Area (% of total land area) of Permanent crop land?
Keep it short and to the point. 40.4. In the year 2008, what is the difference between the Area (% of total land area) in Arable land and Area (% of total land area) in Permanent crop land?
Provide a short and direct response. 0.82. What is the ratio of the Area (% of total land area) of Terrestrial protected areas in 2001 to that in 2002?
Provide a succinct answer. 1. What is the ratio of the Area (% of total land area) of Arable land in 2001 to that in 2002?
Give a very brief answer. 0.97. What is the ratio of the Area (% of total land area) in Permanent crop land in 2001 to that in 2002?
Offer a very short reply. 0.96. What is the ratio of the Area (% of total land area) of Terrestrial protected areas in 2001 to that in 2003?
Offer a very short reply. 1. What is the ratio of the Area (% of total land area) of Arable land in 2001 to that in 2003?
Your answer should be very brief. 0.93. What is the ratio of the Area (% of total land area) of Permanent crop land in 2001 to that in 2003?
Ensure brevity in your answer.  0.84. What is the ratio of the Area (% of total land area) in Terrestrial protected areas in 2001 to that in 2004?
Offer a very short reply. 1. What is the ratio of the Area (% of total land area) of Agricultural land in 2001 to that in 2004?
Your response must be concise. 1. What is the ratio of the Area (% of total land area) of Arable land in 2001 to that in 2004?
Your answer should be very brief. 0.9. What is the ratio of the Area (% of total land area) in Permanent crop land in 2001 to that in 2004?
Your response must be concise. 1.05. What is the ratio of the Area (% of total land area) in Agricultural land in 2001 to that in 2005?
Ensure brevity in your answer.  1. What is the ratio of the Area (% of total land area) of Arable land in 2001 to that in 2005?
Your response must be concise. 0.86. What is the ratio of the Area (% of total land area) of Permanent crop land in 2001 to that in 2005?
Make the answer very short. 0.96. What is the ratio of the Area (% of total land area) in Terrestrial protected areas in 2001 to that in 2006?
Give a very brief answer. 1. What is the ratio of the Area (% of total land area) of Agricultural land in 2001 to that in 2006?
Make the answer very short. 1. What is the ratio of the Area (% of total land area) in Permanent crop land in 2001 to that in 2006?
Ensure brevity in your answer.  1.05. What is the ratio of the Area (% of total land area) in Terrestrial protected areas in 2001 to that in 2007?
Provide a succinct answer. 1. What is the ratio of the Area (% of total land area) of Agricultural land in 2001 to that in 2007?
Provide a short and direct response. 1. What is the ratio of the Area (% of total land area) of Arable land in 2001 to that in 2007?
Provide a succinct answer. 0.81. What is the ratio of the Area (% of total land area) of Permanent crop land in 2001 to that in 2007?
Offer a terse response. 1.02. What is the ratio of the Area (% of total land area) in Arable land in 2001 to that in 2008?
Give a very brief answer. 0.79. What is the ratio of the Area (% of total land area) in Permanent crop land in 2001 to that in 2008?
Your response must be concise. 0.97. What is the ratio of the Area (% of total land area) in Agricultural land in 2002 to that in 2003?
Provide a succinct answer. 1. What is the ratio of the Area (% of total land area) of Arable land in 2002 to that in 2003?
Keep it short and to the point. 0.96. What is the ratio of the Area (% of total land area) in Permanent crop land in 2002 to that in 2003?
Provide a short and direct response. 0.88. What is the ratio of the Area (% of total land area) of Arable land in 2002 to that in 2004?
Make the answer very short. 0.93. What is the ratio of the Area (% of total land area) in Permanent crop land in 2002 to that in 2004?
Provide a succinct answer. 1.09. What is the ratio of the Area (% of total land area) of Terrestrial protected areas in 2002 to that in 2005?
Make the answer very short. 1. What is the ratio of the Area (% of total land area) of Agricultural land in 2002 to that in 2005?
Ensure brevity in your answer.  1. What is the ratio of the Area (% of total land area) of Arable land in 2002 to that in 2005?
Your response must be concise. 0.89. What is the ratio of the Area (% of total land area) in Permanent crop land in 2002 to that in 2005?
Offer a terse response. 1. What is the ratio of the Area (% of total land area) in Agricultural land in 2002 to that in 2006?
Make the answer very short. 1. What is the ratio of the Area (% of total land area) in Arable land in 2002 to that in 2006?
Provide a succinct answer. 0.86. What is the ratio of the Area (% of total land area) in Permanent crop land in 2002 to that in 2006?
Your answer should be compact. 1.09. What is the ratio of the Area (% of total land area) of Agricultural land in 2002 to that in 2007?
Provide a succinct answer. 1. What is the ratio of the Area (% of total land area) in Arable land in 2002 to that in 2007?
Keep it short and to the point. 0.84. What is the ratio of the Area (% of total land area) in Permanent crop land in 2002 to that in 2007?
Give a very brief answer. 1.06. What is the ratio of the Area (% of total land area) of Terrestrial protected areas in 2002 to that in 2008?
Your answer should be very brief. 1. What is the ratio of the Area (% of total land area) of Arable land in 2002 to that in 2008?
Offer a terse response. 0.82. What is the ratio of the Area (% of total land area) in Permanent crop land in 2002 to that in 2008?
Keep it short and to the point. 1.01. What is the ratio of the Area (% of total land area) in Terrestrial protected areas in 2003 to that in 2004?
Your response must be concise. 1. What is the ratio of the Area (% of total land area) in Agricultural land in 2003 to that in 2004?
Provide a succinct answer. 1. What is the ratio of the Area (% of total land area) of Arable land in 2003 to that in 2004?
Offer a very short reply. 0.96. What is the ratio of the Area (% of total land area) of Permanent crop land in 2003 to that in 2004?
Your answer should be very brief. 1.25. What is the ratio of the Area (% of total land area) of Terrestrial protected areas in 2003 to that in 2005?
Provide a short and direct response. 1. What is the ratio of the Area (% of total land area) in Agricultural land in 2003 to that in 2005?
Provide a succinct answer. 1. What is the ratio of the Area (% of total land area) in Arable land in 2003 to that in 2005?
Offer a very short reply. 0.93. What is the ratio of the Area (% of total land area) in Terrestrial protected areas in 2003 to that in 2006?
Offer a terse response. 1. What is the ratio of the Area (% of total land area) in Arable land in 2003 to that in 2006?
Your response must be concise. 0.9. What is the ratio of the Area (% of total land area) of Permanent crop land in 2003 to that in 2006?
Give a very brief answer. 1.25. What is the ratio of the Area (% of total land area) in Agricultural land in 2003 to that in 2007?
Give a very brief answer. 1. What is the ratio of the Area (% of total land area) of Arable land in 2003 to that in 2007?
Your answer should be compact. 0.87. What is the ratio of the Area (% of total land area) in Permanent crop land in 2003 to that in 2007?
Offer a very short reply. 1.21. What is the ratio of the Area (% of total land area) in Terrestrial protected areas in 2003 to that in 2008?
Provide a short and direct response. 1. What is the ratio of the Area (% of total land area) of Agricultural land in 2003 to that in 2008?
Make the answer very short. 1. What is the ratio of the Area (% of total land area) in Arable land in 2003 to that in 2008?
Provide a short and direct response. 0.85. What is the ratio of the Area (% of total land area) in Permanent crop land in 2003 to that in 2008?
Make the answer very short. 1.16. What is the ratio of the Area (% of total land area) of Agricultural land in 2004 to that in 2005?
Offer a very short reply. 1. What is the ratio of the Area (% of total land area) in Arable land in 2004 to that in 2005?
Provide a succinct answer. 0.96. What is the ratio of the Area (% of total land area) in Permanent crop land in 2004 to that in 2005?
Make the answer very short. 0.91. What is the ratio of the Area (% of total land area) of Agricultural land in 2004 to that in 2006?
Your response must be concise. 1. What is the ratio of the Area (% of total land area) in Permanent crop land in 2004 to that in 2006?
Keep it short and to the point. 1. What is the ratio of the Area (% of total land area) in Arable land in 2004 to that in 2007?
Your answer should be very brief. 0.91. What is the ratio of the Area (% of total land area) of Permanent crop land in 2004 to that in 2007?
Your answer should be very brief. 0.97. What is the ratio of the Area (% of total land area) in Agricultural land in 2004 to that in 2008?
Offer a very short reply. 1. What is the ratio of the Area (% of total land area) of Arable land in 2004 to that in 2008?
Ensure brevity in your answer.  0.88. What is the ratio of the Area (% of total land area) in Permanent crop land in 2004 to that in 2008?
Ensure brevity in your answer.  0.93. What is the ratio of the Area (% of total land area) in Terrestrial protected areas in 2005 to that in 2006?
Provide a succinct answer. 1. What is the ratio of the Area (% of total land area) in Arable land in 2005 to that in 2006?
Your response must be concise. 0.97. What is the ratio of the Area (% of total land area) of Permanent crop land in 2005 to that in 2006?
Offer a terse response. 1.09. What is the ratio of the Area (% of total land area) in Terrestrial protected areas in 2005 to that in 2007?
Keep it short and to the point. 1. What is the ratio of the Area (% of total land area) of Agricultural land in 2005 to that in 2007?
Make the answer very short. 1. What is the ratio of the Area (% of total land area) of Arable land in 2005 to that in 2007?
Offer a very short reply. 0.94. What is the ratio of the Area (% of total land area) of Permanent crop land in 2005 to that in 2007?
Your answer should be compact. 1.06. What is the ratio of the Area (% of total land area) of Terrestrial protected areas in 2005 to that in 2008?
Make the answer very short. 1. What is the ratio of the Area (% of total land area) in Arable land in 2005 to that in 2008?
Provide a succinct answer. 0.91. What is the ratio of the Area (% of total land area) of Permanent crop land in 2005 to that in 2008?
Your answer should be compact. 1.01. What is the ratio of the Area (% of total land area) in Arable land in 2006 to that in 2007?
Make the answer very short. 0.97. What is the ratio of the Area (% of total land area) in Permanent crop land in 2006 to that in 2007?
Your answer should be very brief. 0.97. What is the ratio of the Area (% of total land area) of Terrestrial protected areas in 2006 to that in 2008?
Provide a short and direct response. 1. What is the ratio of the Area (% of total land area) in Agricultural land in 2006 to that in 2008?
Ensure brevity in your answer.  1. What is the ratio of the Area (% of total land area) of Arable land in 2006 to that in 2008?
Your response must be concise. 0.95. What is the ratio of the Area (% of total land area) of Permanent crop land in 2006 to that in 2008?
Your answer should be compact. 0.93. What is the ratio of the Area (% of total land area) of Terrestrial protected areas in 2007 to that in 2008?
Your answer should be compact. 1. What is the ratio of the Area (% of total land area) of Arable land in 2007 to that in 2008?
Keep it short and to the point. 0.97. What is the ratio of the Area (% of total land area) of Permanent crop land in 2007 to that in 2008?
Ensure brevity in your answer.  0.96. What is the difference between the highest and the second highest Area (% of total land area) of Agricultural land?
Your answer should be compact. 0.02. What is the difference between the highest and the second highest Area (% of total land area) in Arable land?
Provide a succinct answer. 0.02. What is the difference between the highest and the second highest Area (% of total land area) of Permanent crop land?
Ensure brevity in your answer.  0. What is the difference between the highest and the lowest Area (% of total land area) of Terrestrial protected areas?
Provide a short and direct response. 0. What is the difference between the highest and the lowest Area (% of total land area) in Agricultural land?
Provide a short and direct response. 0.18. What is the difference between the highest and the lowest Area (% of total land area) of Arable land?
Ensure brevity in your answer.  0.18. What is the difference between the highest and the lowest Area (% of total land area) of Permanent crop land?
Offer a very short reply. 0.01. 